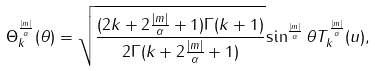Convert formula to latex. <formula><loc_0><loc_0><loc_500><loc_500>\Theta _ { k } ^ { \frac { | m | } { \alpha } } ( \theta ) = \sqrt { \frac { ( 2 k + 2 { \frac { | m | } { \alpha } } + 1 ) \Gamma ( k + 1 ) } { 2 \Gamma ( k + 2 { \frac { | m | } { \alpha } } + 1 ) } } { \sin ^ { \frac { | m | } { \alpha } } \theta } T _ { k } ^ { \frac { | m | } { \alpha } } ( u ) ,</formula> 